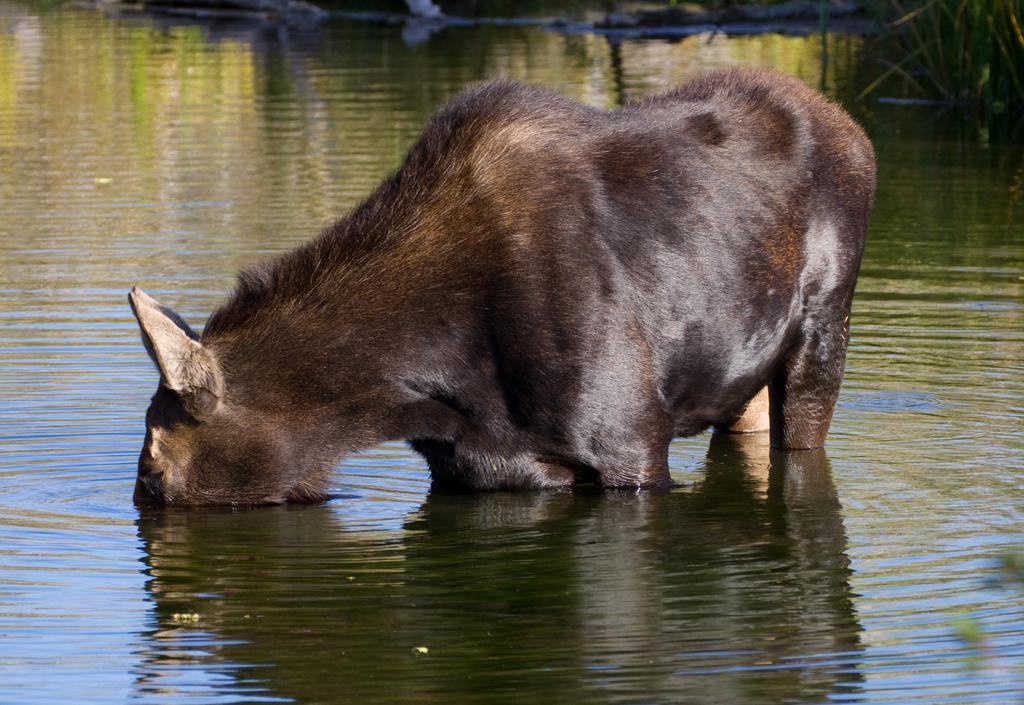In one or two sentences, can you explain what this image depicts? An animal is in water and drinking, it is in black color. 